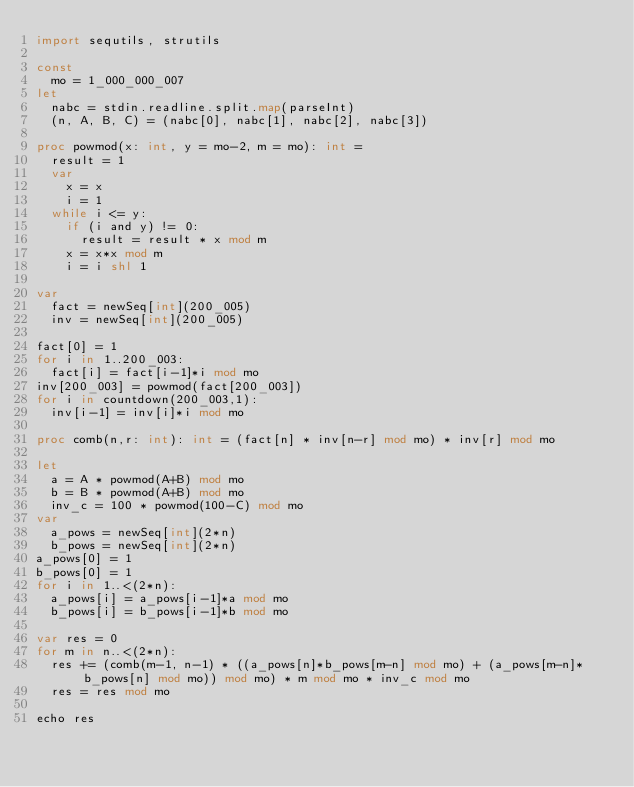<code> <loc_0><loc_0><loc_500><loc_500><_Nim_>import sequtils, strutils

const
  mo = 1_000_000_007
let
  nabc = stdin.readline.split.map(parseInt)
  (n, A, B, C) = (nabc[0], nabc[1], nabc[2], nabc[3])

proc powmod(x: int, y = mo-2, m = mo): int =
  result = 1
  var
    x = x
    i = 1
  while i <= y:
    if (i and y) != 0:
      result = result * x mod m
    x = x*x mod m
    i = i shl 1

var
  fact = newSeq[int](200_005)
  inv = newSeq[int](200_005)

fact[0] = 1
for i in 1..200_003:
  fact[i] = fact[i-1]*i mod mo
inv[200_003] = powmod(fact[200_003])
for i in countdown(200_003,1):
  inv[i-1] = inv[i]*i mod mo

proc comb(n,r: int): int = (fact[n] * inv[n-r] mod mo) * inv[r] mod mo

let
  a = A * powmod(A+B) mod mo
  b = B * powmod(A+B) mod mo
  inv_c = 100 * powmod(100-C) mod mo
var
  a_pows = newSeq[int](2*n)
  b_pows = newSeq[int](2*n)
a_pows[0] = 1
b_pows[0] = 1
for i in 1..<(2*n):
  a_pows[i] = a_pows[i-1]*a mod mo
  b_pows[i] = b_pows[i-1]*b mod mo

var res = 0
for m in n..<(2*n):
  res += (comb(m-1, n-1) * ((a_pows[n]*b_pows[m-n] mod mo) + (a_pows[m-n]*b_pows[n] mod mo)) mod mo) * m mod mo * inv_c mod mo
  res = res mod mo

echo res
</code> 